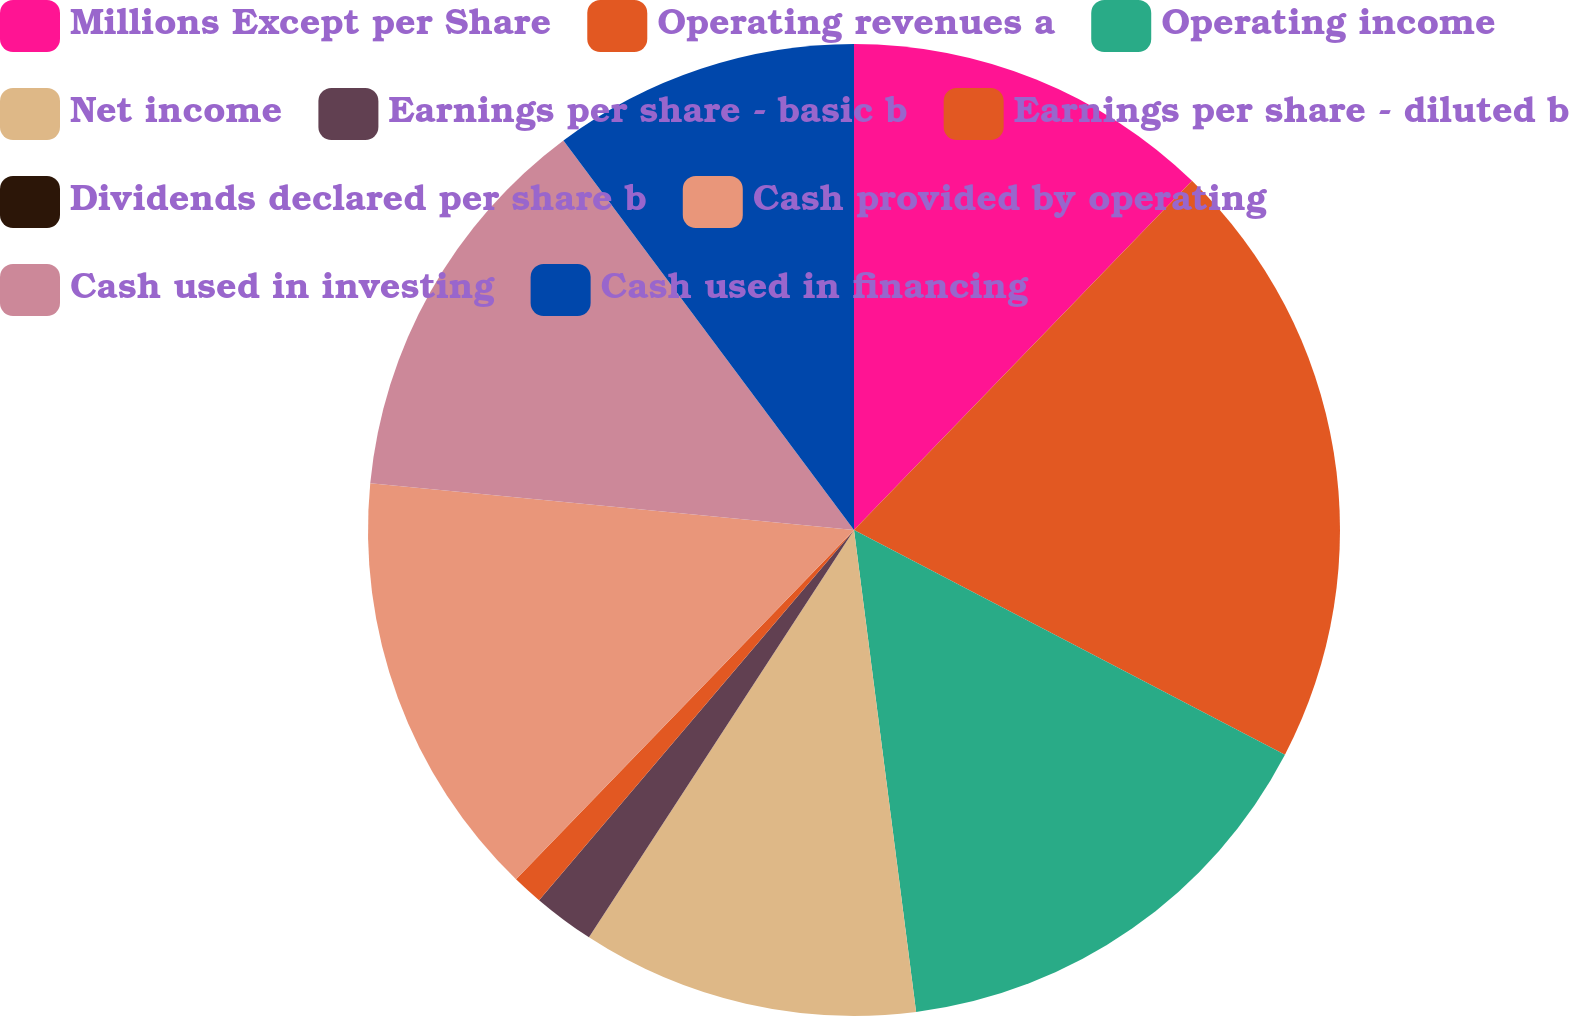Convert chart. <chart><loc_0><loc_0><loc_500><loc_500><pie_chart><fcel>Millions Except per Share<fcel>Operating revenues a<fcel>Operating income<fcel>Net income<fcel>Earnings per share - basic b<fcel>Earnings per share - diluted b<fcel>Dividends declared per share b<fcel>Cash provided by operating<fcel>Cash used in investing<fcel>Cash used in financing<nl><fcel>12.24%<fcel>20.41%<fcel>15.31%<fcel>11.22%<fcel>2.04%<fcel>1.02%<fcel>0.0%<fcel>14.29%<fcel>13.27%<fcel>10.2%<nl></chart> 